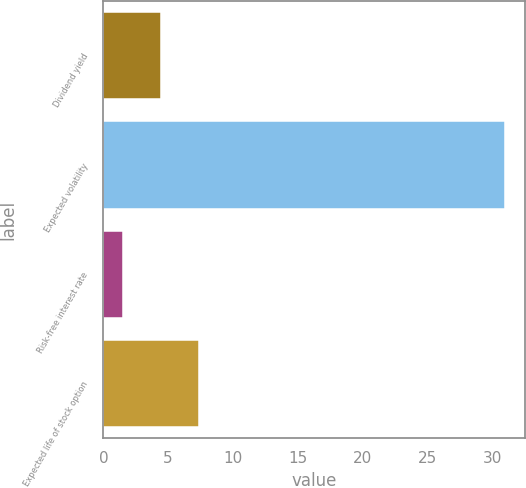Convert chart. <chart><loc_0><loc_0><loc_500><loc_500><bar_chart><fcel>Dividend yield<fcel>Expected volatility<fcel>Risk-free interest rate<fcel>Expected life of stock option<nl><fcel>4.45<fcel>31<fcel>1.5<fcel>7.4<nl></chart> 